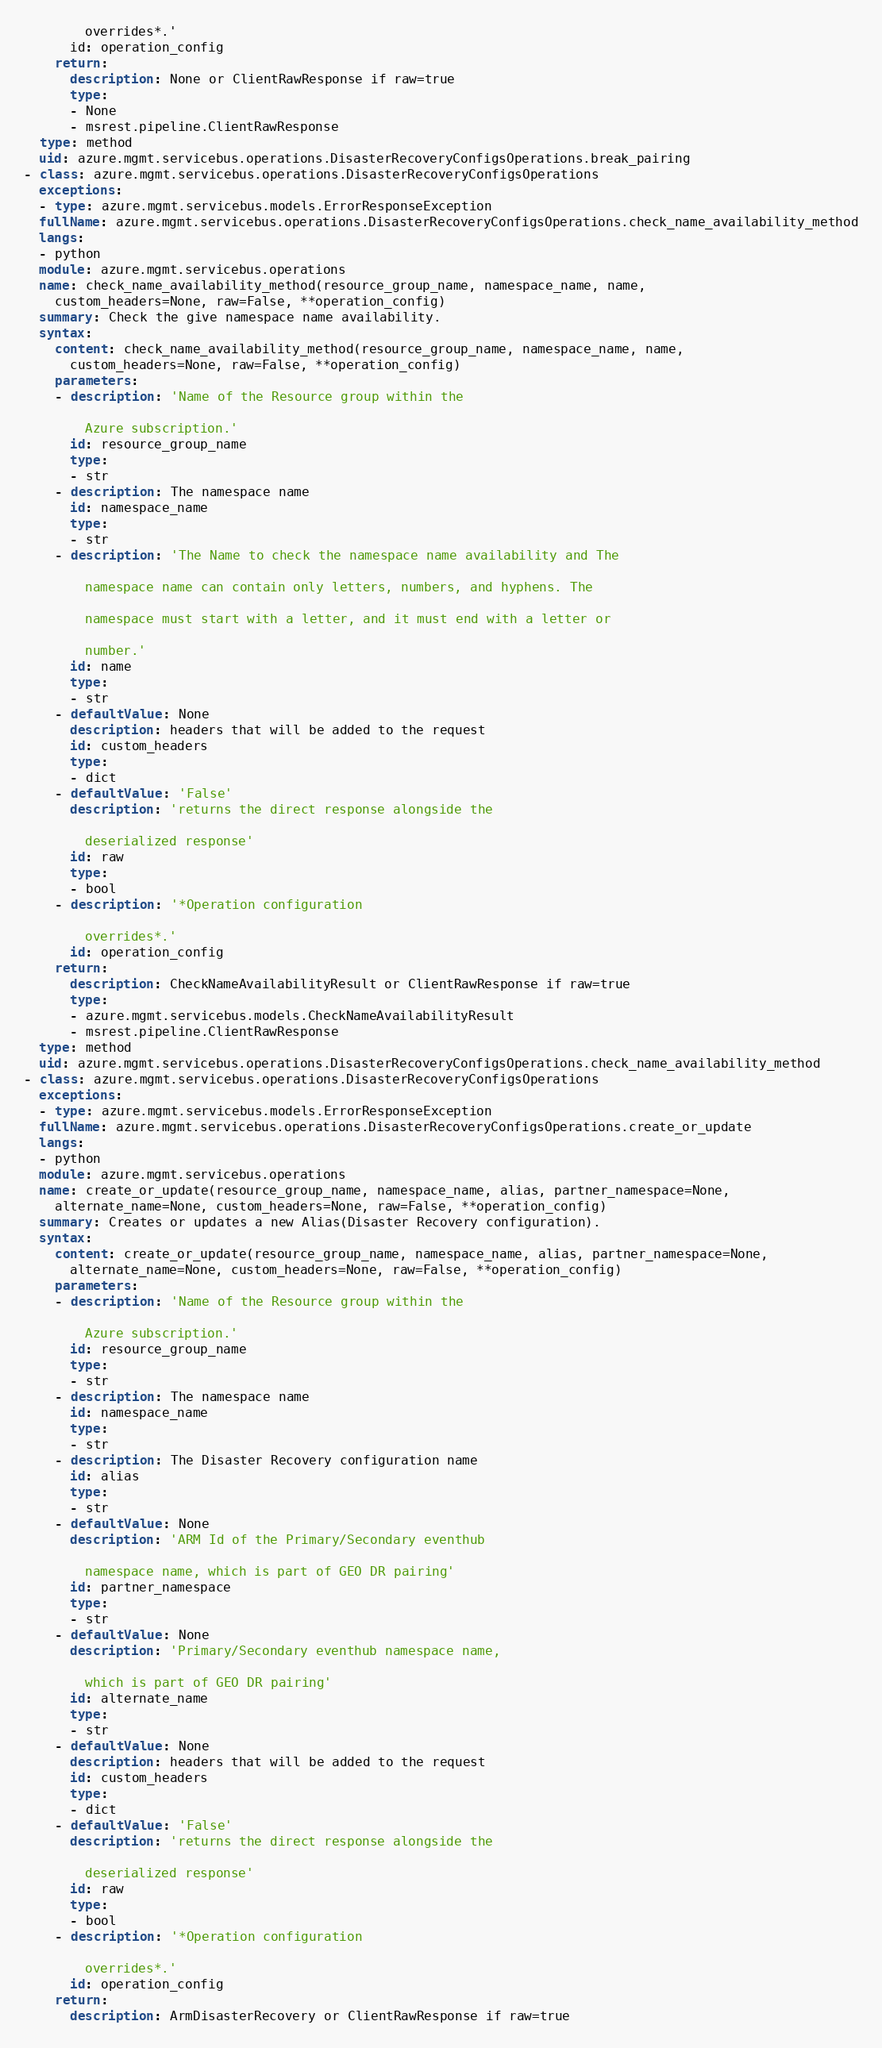Convert code to text. <code><loc_0><loc_0><loc_500><loc_500><_YAML_>
        overrides*.'
      id: operation_config
    return:
      description: None or ClientRawResponse if raw=true
      type:
      - None
      - msrest.pipeline.ClientRawResponse
  type: method
  uid: azure.mgmt.servicebus.operations.DisasterRecoveryConfigsOperations.break_pairing
- class: azure.mgmt.servicebus.operations.DisasterRecoveryConfigsOperations
  exceptions:
  - type: azure.mgmt.servicebus.models.ErrorResponseException
  fullName: azure.mgmt.servicebus.operations.DisasterRecoveryConfigsOperations.check_name_availability_method
  langs:
  - python
  module: azure.mgmt.servicebus.operations
  name: check_name_availability_method(resource_group_name, namespace_name, name,
    custom_headers=None, raw=False, **operation_config)
  summary: Check the give namespace name availability.
  syntax:
    content: check_name_availability_method(resource_group_name, namespace_name, name,
      custom_headers=None, raw=False, **operation_config)
    parameters:
    - description: 'Name of the Resource group within the

        Azure subscription.'
      id: resource_group_name
      type:
      - str
    - description: The namespace name
      id: namespace_name
      type:
      - str
    - description: 'The Name to check the namespace name availability and The

        namespace name can contain only letters, numbers, and hyphens. The

        namespace must start with a letter, and it must end with a letter or

        number.'
      id: name
      type:
      - str
    - defaultValue: None
      description: headers that will be added to the request
      id: custom_headers
      type:
      - dict
    - defaultValue: 'False'
      description: 'returns the direct response alongside the

        deserialized response'
      id: raw
      type:
      - bool
    - description: '*Operation configuration

        overrides*.'
      id: operation_config
    return:
      description: CheckNameAvailabilityResult or ClientRawResponse if raw=true
      type:
      - azure.mgmt.servicebus.models.CheckNameAvailabilityResult
      - msrest.pipeline.ClientRawResponse
  type: method
  uid: azure.mgmt.servicebus.operations.DisasterRecoveryConfigsOperations.check_name_availability_method
- class: azure.mgmt.servicebus.operations.DisasterRecoveryConfigsOperations
  exceptions:
  - type: azure.mgmt.servicebus.models.ErrorResponseException
  fullName: azure.mgmt.servicebus.operations.DisasterRecoveryConfigsOperations.create_or_update
  langs:
  - python
  module: azure.mgmt.servicebus.operations
  name: create_or_update(resource_group_name, namespace_name, alias, partner_namespace=None,
    alternate_name=None, custom_headers=None, raw=False, **operation_config)
  summary: Creates or updates a new Alias(Disaster Recovery configuration).
  syntax:
    content: create_or_update(resource_group_name, namespace_name, alias, partner_namespace=None,
      alternate_name=None, custom_headers=None, raw=False, **operation_config)
    parameters:
    - description: 'Name of the Resource group within the

        Azure subscription.'
      id: resource_group_name
      type:
      - str
    - description: The namespace name
      id: namespace_name
      type:
      - str
    - description: The Disaster Recovery configuration name
      id: alias
      type:
      - str
    - defaultValue: None
      description: 'ARM Id of the Primary/Secondary eventhub

        namespace name, which is part of GEO DR pairing'
      id: partner_namespace
      type:
      - str
    - defaultValue: None
      description: 'Primary/Secondary eventhub namespace name,

        which is part of GEO DR pairing'
      id: alternate_name
      type:
      - str
    - defaultValue: None
      description: headers that will be added to the request
      id: custom_headers
      type:
      - dict
    - defaultValue: 'False'
      description: 'returns the direct response alongside the

        deserialized response'
      id: raw
      type:
      - bool
    - description: '*Operation configuration

        overrides*.'
      id: operation_config
    return:
      description: ArmDisasterRecovery or ClientRawResponse if raw=true</code> 